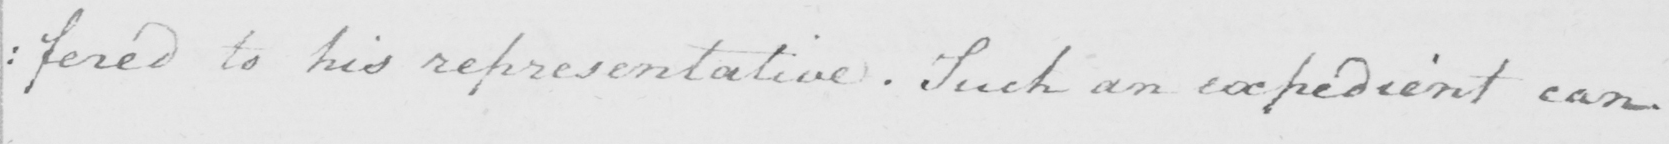What text is written in this handwritten line? : fered to his representative  . Such an expedient can 